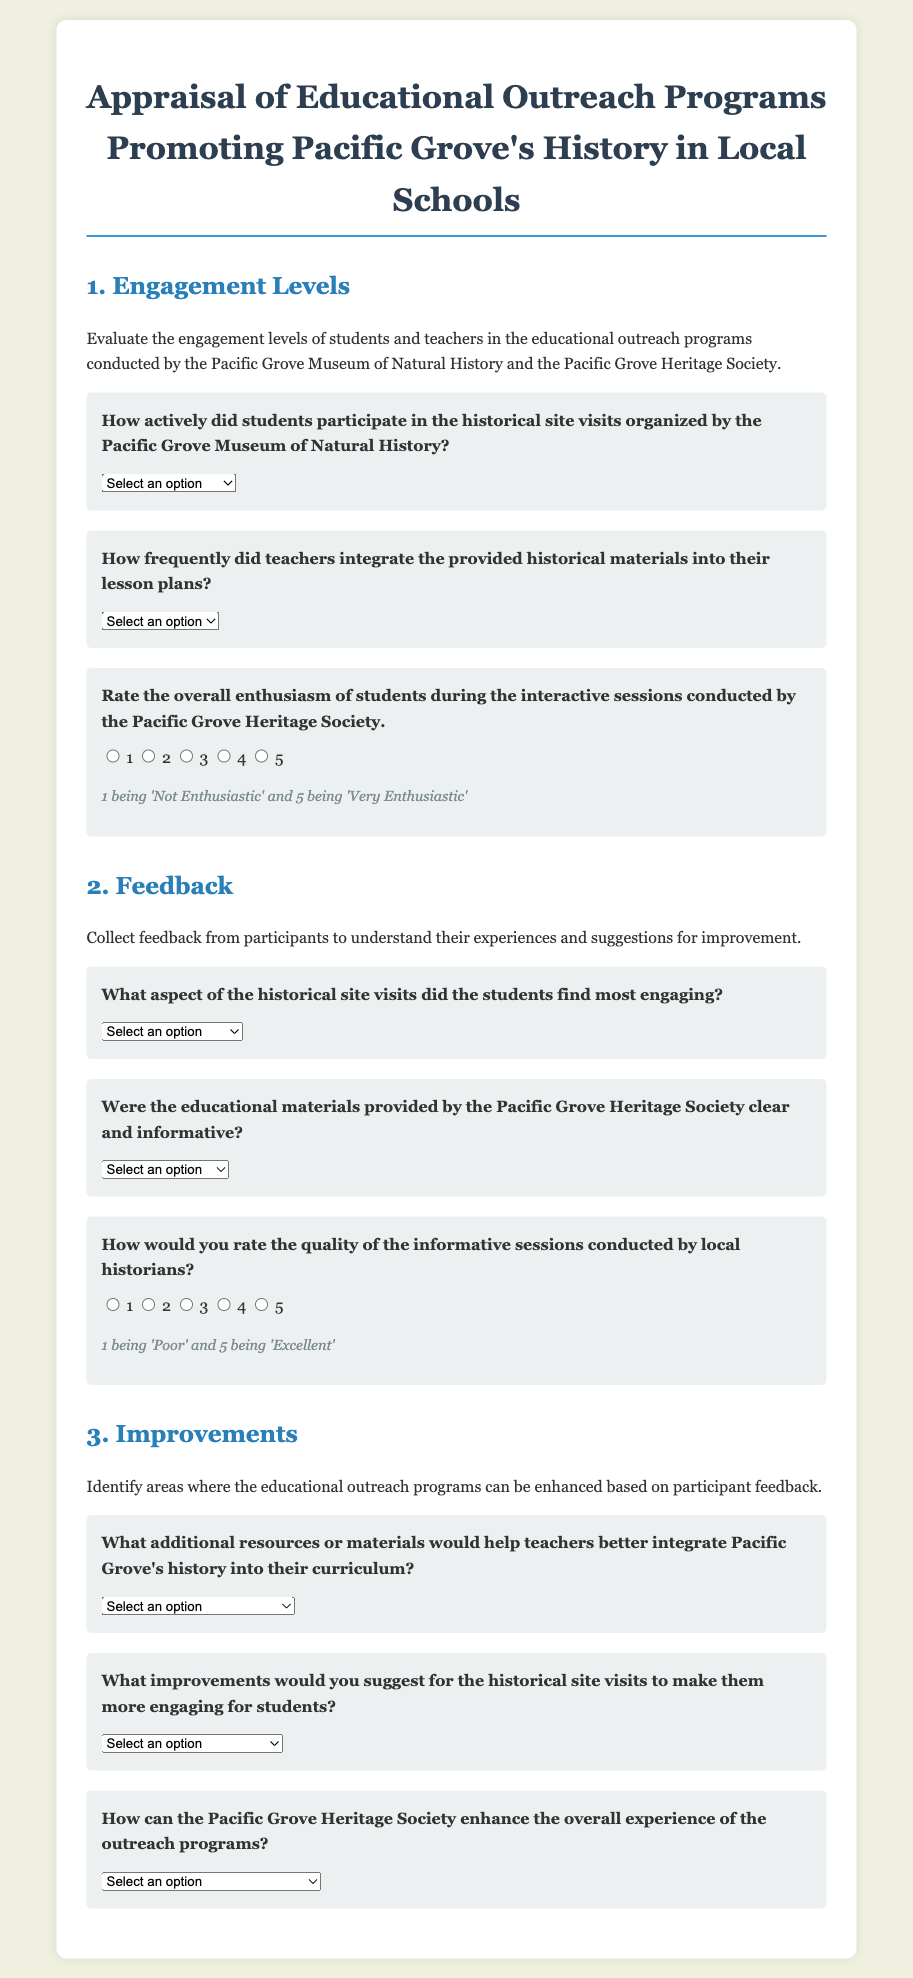What is the title of the appraisal form? The title is stated at the top of the document, indicating the focus of the evaluation.
Answer: Appraisal of Educational Outreach Programs Promoting Pacific Grove's History in Local Schools How many sections are in the document? The document is divided into three main sections addressing different aspects of the programs.
Answer: Three What is the first question regarding student participation? The first question specifically evaluates student participation during a type of program activity.
Answer: How actively did students participate in the historical site visits organized by the Pacific Grove Museum of Natural History? What option is available for teachers' integration frequency? The options for this question assess how often teachers included the provided materials in their lesson plans.
Answer: Very Frequently What scale is used to rate enthusiasm during interactive sessions? The document specifies a numerical scale for rating students' enthusiasm levels during sessions.
Answer: 1 to 5 